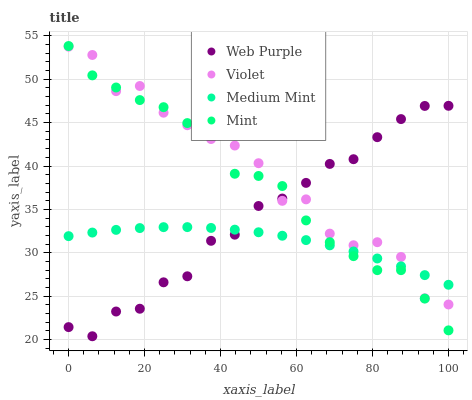Does Medium Mint have the minimum area under the curve?
Answer yes or no. Yes. Does Violet have the maximum area under the curve?
Answer yes or no. Yes. Does Web Purple have the minimum area under the curve?
Answer yes or no. No. Does Web Purple have the maximum area under the curve?
Answer yes or no. No. Is Medium Mint the smoothest?
Answer yes or no. Yes. Is Violet the roughest?
Answer yes or no. Yes. Is Web Purple the smoothest?
Answer yes or no. No. Is Web Purple the roughest?
Answer yes or no. No. Does Web Purple have the lowest value?
Answer yes or no. Yes. Does Mint have the lowest value?
Answer yes or no. No. Does Mint have the highest value?
Answer yes or no. Yes. Does Web Purple have the highest value?
Answer yes or no. No. Does Medium Mint intersect Mint?
Answer yes or no. Yes. Is Medium Mint less than Mint?
Answer yes or no. No. Is Medium Mint greater than Mint?
Answer yes or no. No. 